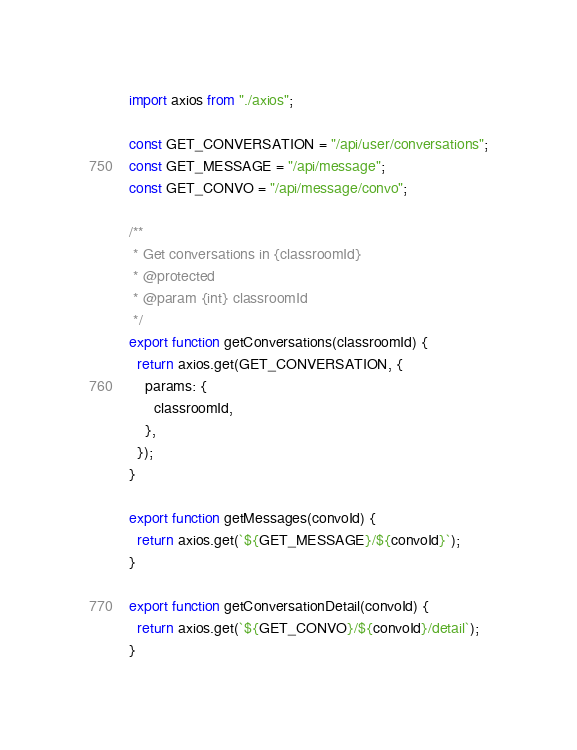<code> <loc_0><loc_0><loc_500><loc_500><_JavaScript_>import axios from "./axios";

const GET_CONVERSATION = "/api/user/conversations";
const GET_MESSAGE = "/api/message";
const GET_CONVO = "/api/message/convo";

/**
 * Get conversations in {classroomId}
 * @protected
 * @param {int} classroomId
 */
export function getConversations(classroomId) {
  return axios.get(GET_CONVERSATION, {
    params: {
      classroomId,
    },
  });
}

export function getMessages(convoId) {
  return axios.get(`${GET_MESSAGE}/${convoId}`);
}

export function getConversationDetail(convoId) {
  return axios.get(`${GET_CONVO}/${convoId}/detail`);
}
</code> 